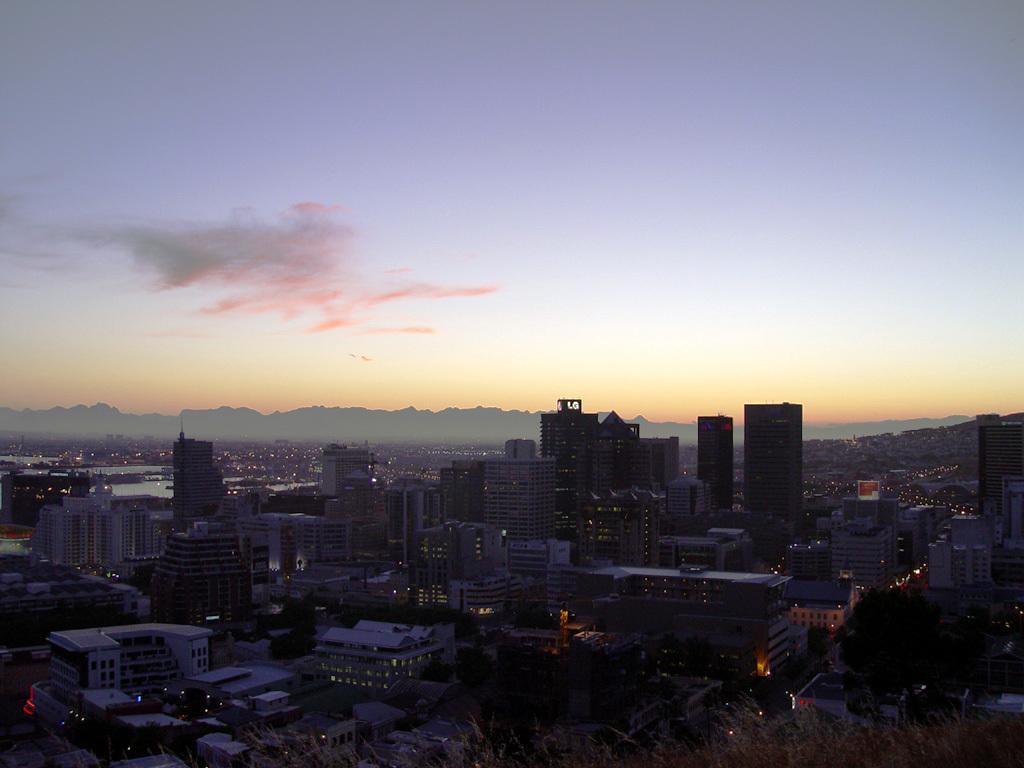Describe this image in one or two sentences. In this image, I can see the view of the city with the buildings, skyscrapers and trees. These are the clouds in the sky. I think here is the water. 